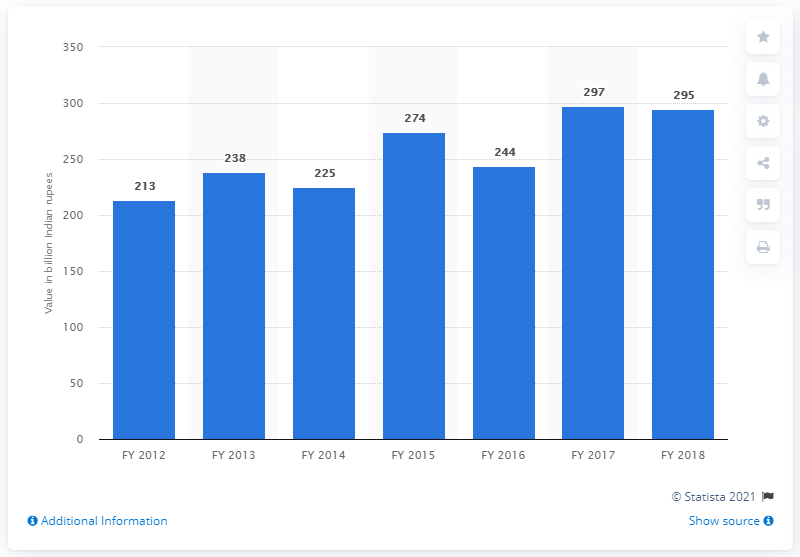Draw attention to some important aspects in this diagram. In fiscal year 2018, potatoes contributed approximately 295 billion Indian rupees to the Indian economy. The blue bar reached its peak in FY 2017. The median value across all the FYs is 241. 